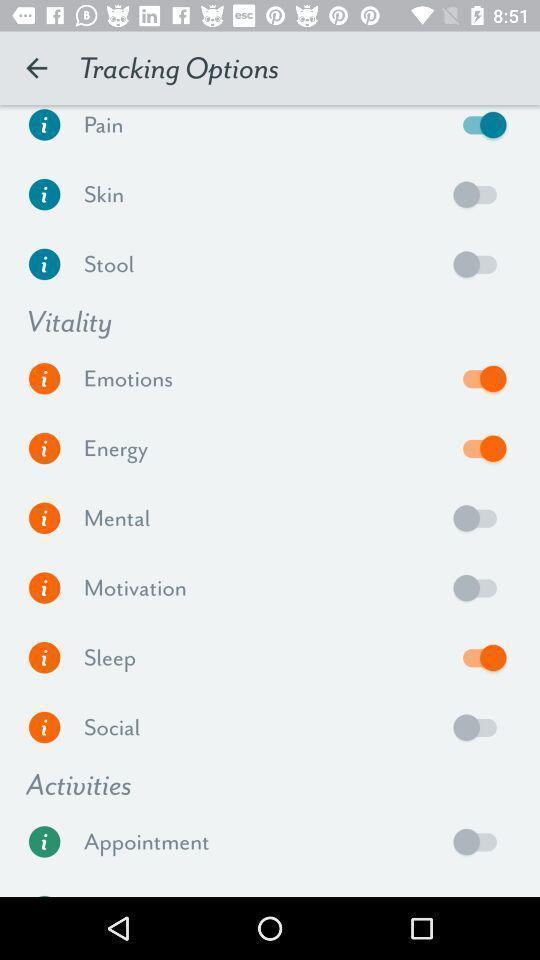Tell me about the visual elements in this screen capture. Screen displaying the options for tracking. 